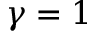Convert formula to latex. <formula><loc_0><loc_0><loc_500><loc_500>\gamma = 1</formula> 